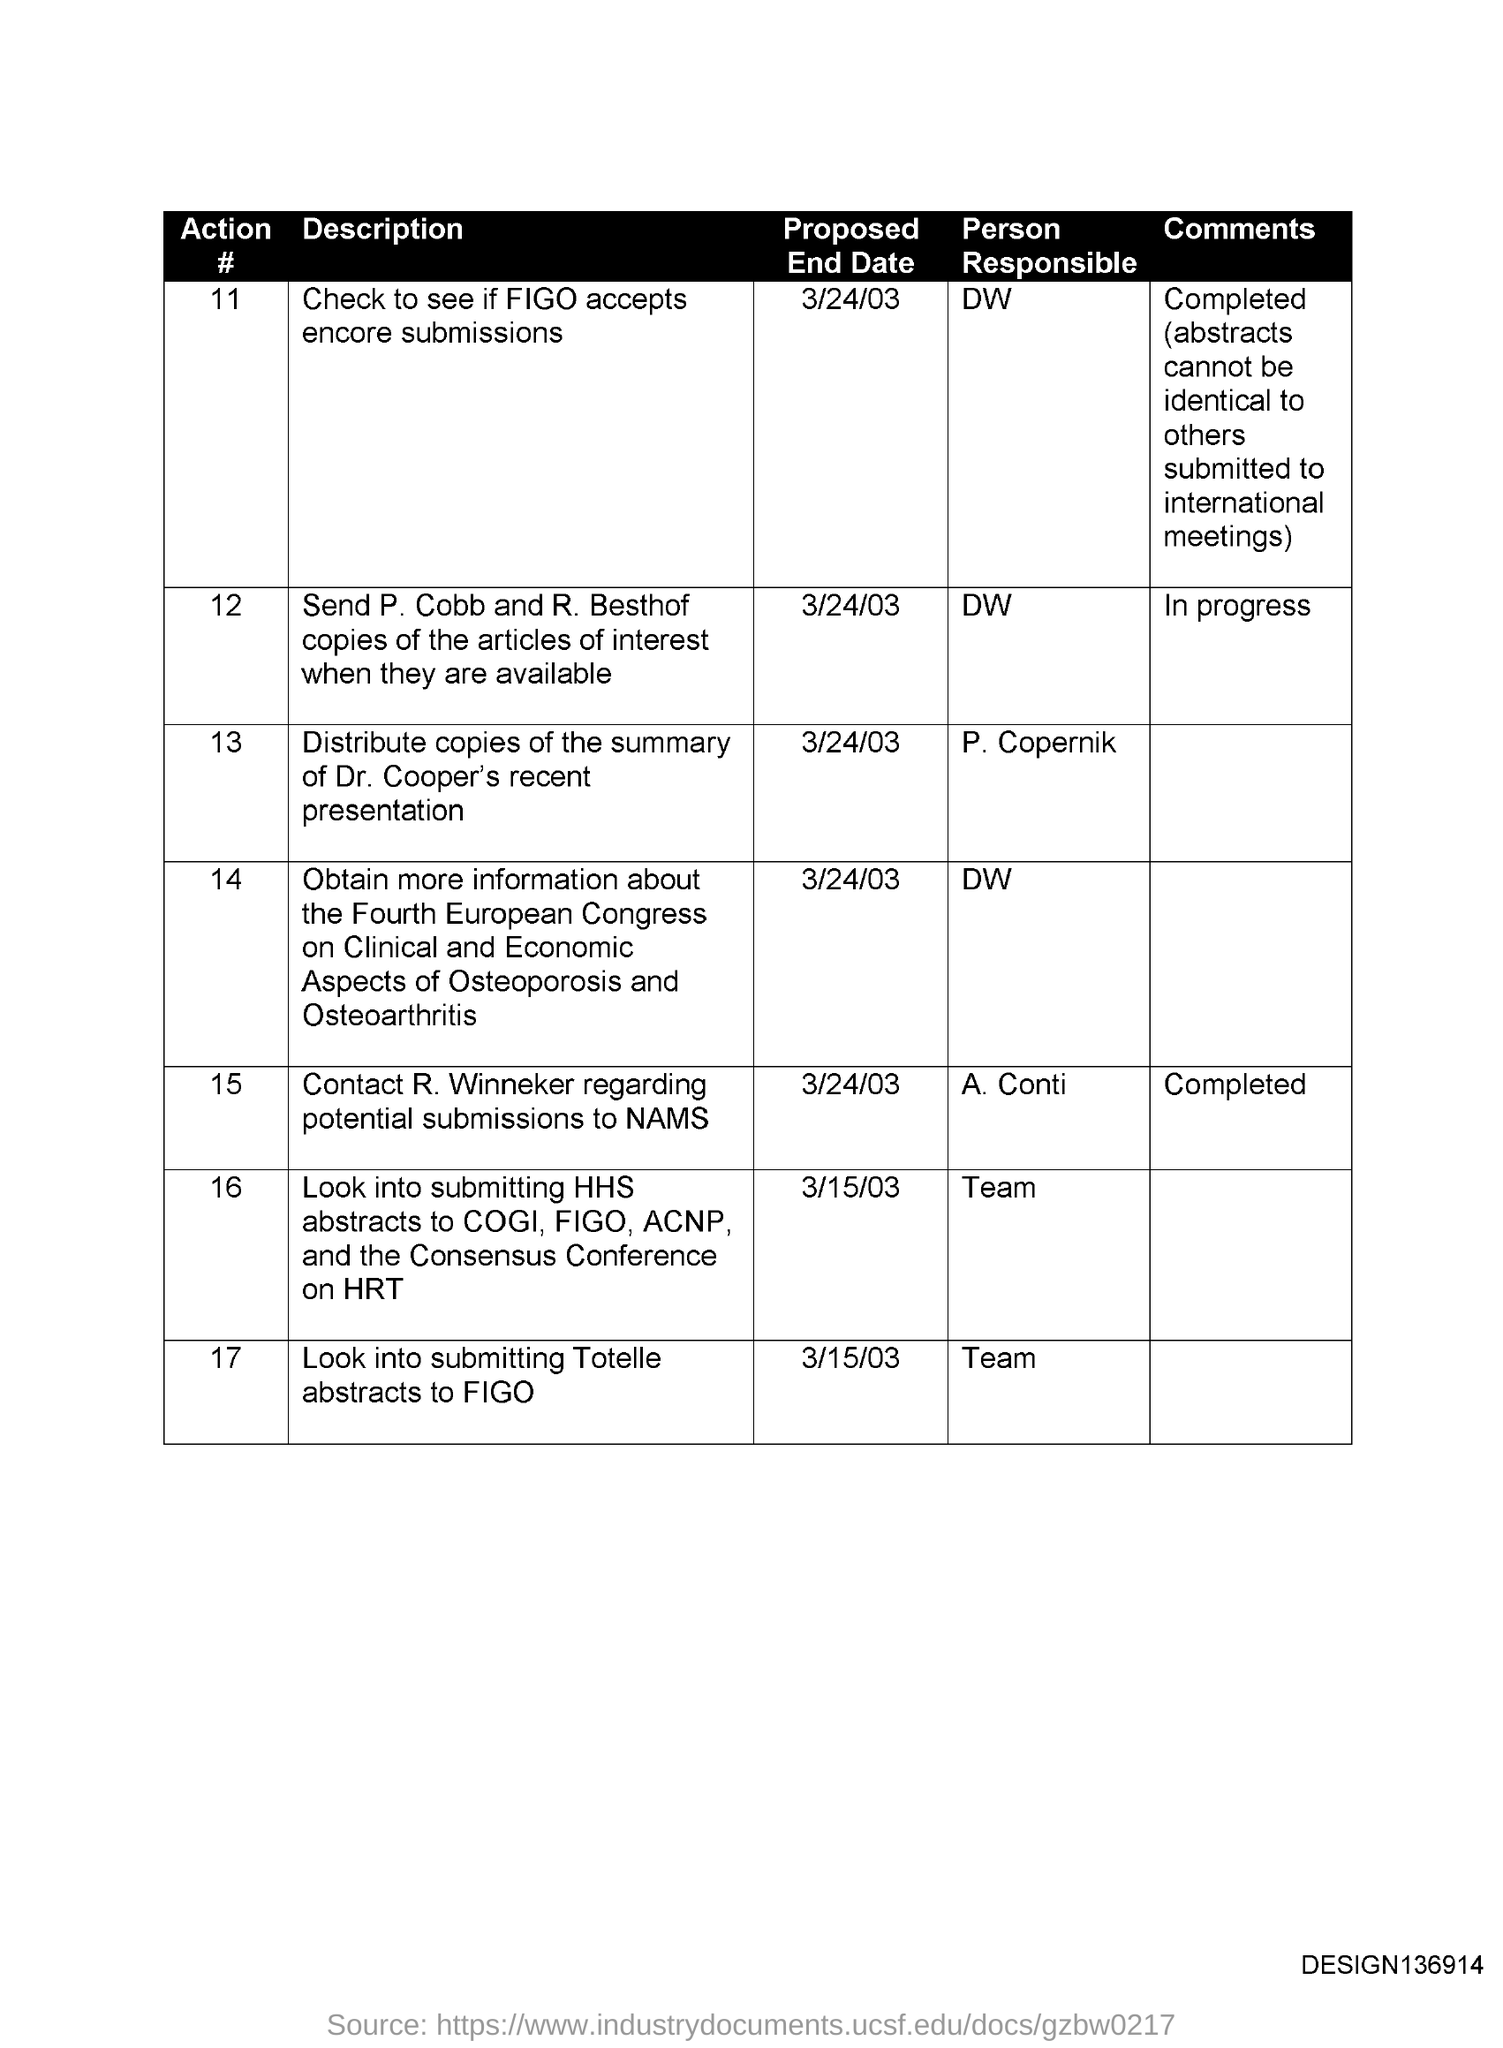What is the proposed end date for Action # 11?
Keep it short and to the point. 3/24/03. Who is the person responsible for action # 11?
Make the answer very short. DW. What is the comments for Action # 12?
Provide a succinct answer. IN PROGRESS. What is the heading for second column?
Your response must be concise. DESCRIPTION. What is the code on the bottom right corner?
Your answer should be compact. DESIGN136914. 